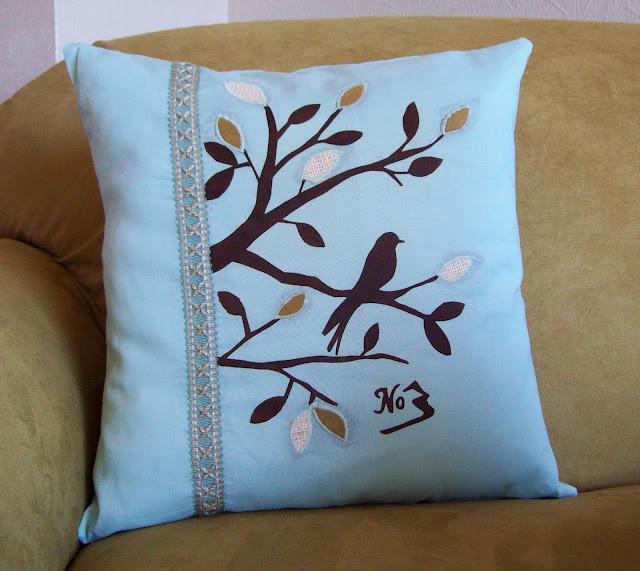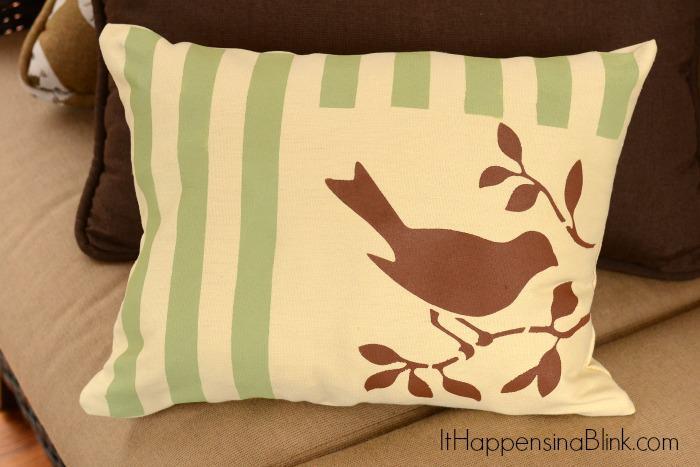The first image is the image on the left, the second image is the image on the right. Considering the images on both sides, is "There are at least 2 pillows in the right image." valid? Answer yes or no. Yes. 